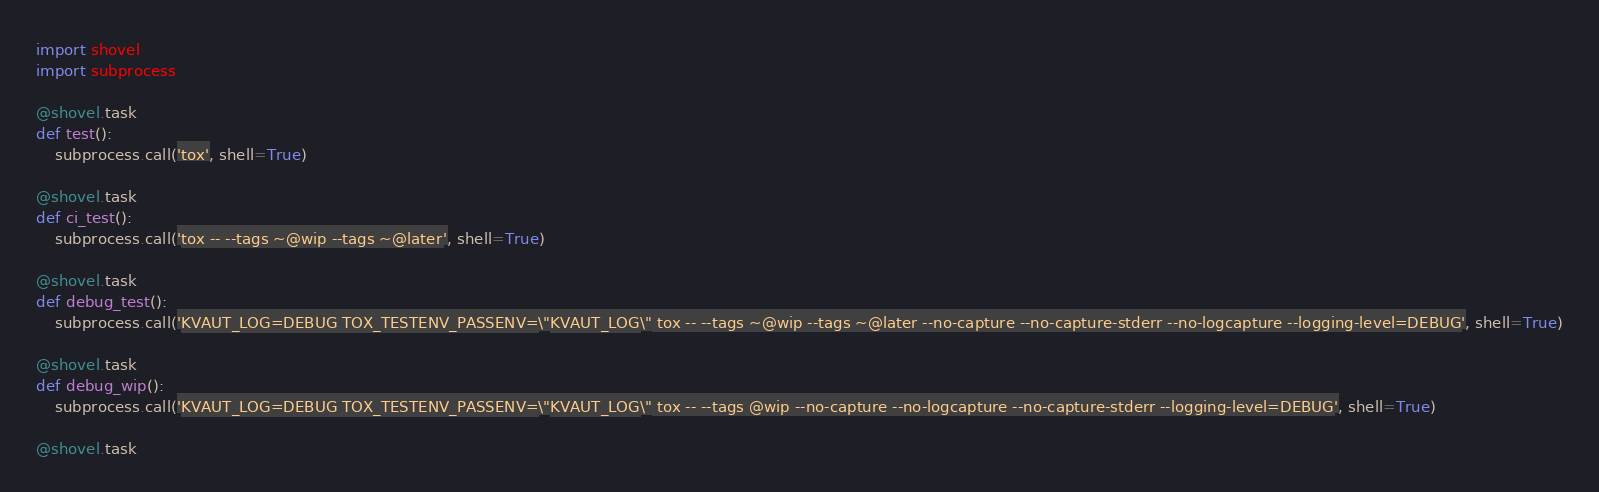<code> <loc_0><loc_0><loc_500><loc_500><_Python_>import shovel
import subprocess

@shovel.task
def test():
    subprocess.call('tox', shell=True)

@shovel.task
def ci_test():
    subprocess.call('tox -- --tags ~@wip --tags ~@later', shell=True)

@shovel.task
def debug_test():
    subprocess.call('KVAUT_LOG=DEBUG TOX_TESTENV_PASSENV=\"KVAUT_LOG\" tox -- --tags ~@wip --tags ~@later --no-capture --no-capture-stderr --no-logcapture --logging-level=DEBUG', shell=True)

@shovel.task
def debug_wip():
    subprocess.call('KVAUT_LOG=DEBUG TOX_TESTENV_PASSENV=\"KVAUT_LOG\" tox -- --tags @wip --no-capture --no-logcapture --no-capture-stderr --logging-level=DEBUG', shell=True)

@shovel.task</code> 